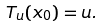<formula> <loc_0><loc_0><loc_500><loc_500>T _ { u } ( x _ { 0 } ) = u .</formula> 